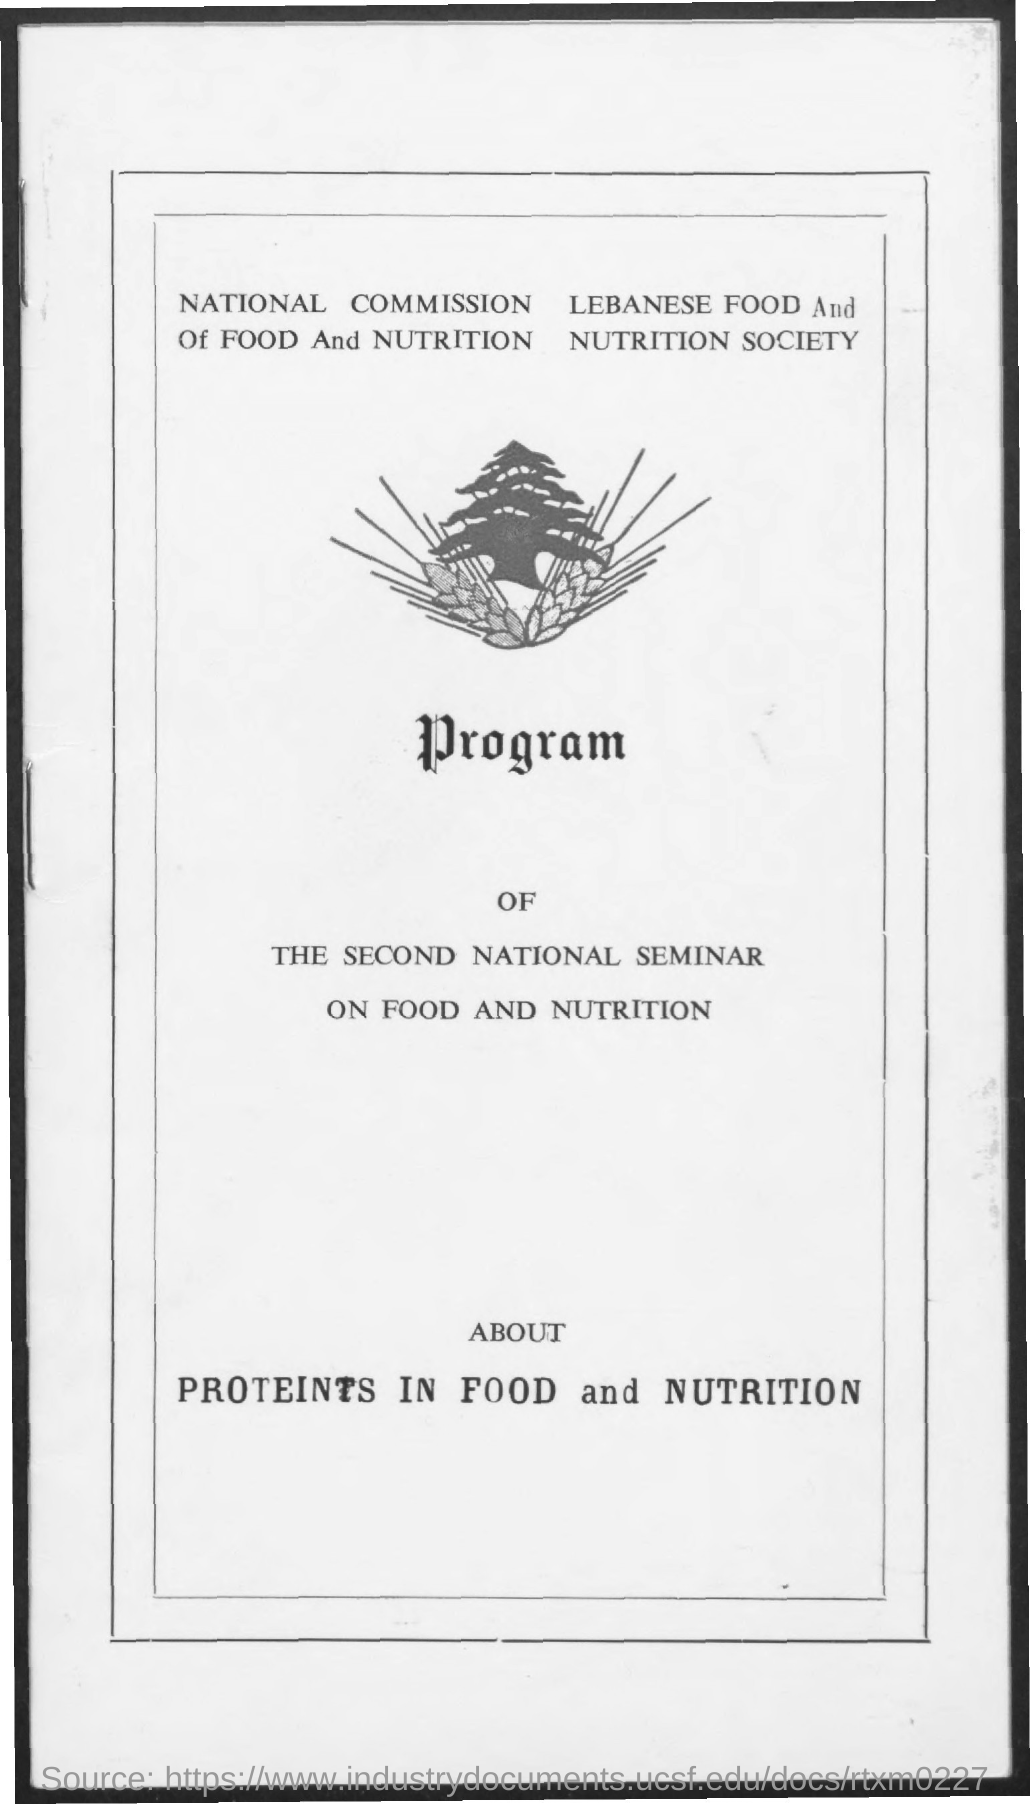Highlight a few significant elements in this photo. The text that is located below the image is "Program... I hereby declare that the name of the commission is the National Commission of Food and Nutrition. The program is about the subject of proteins in food and nutrition. The name of the society is the Lebanese Food and Nutrition Society. 